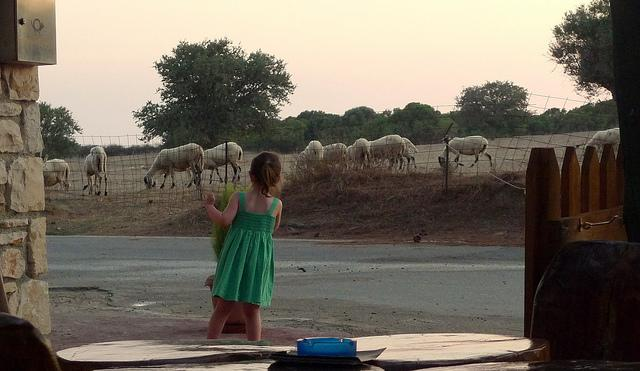What does the girl want to pet? sheep 